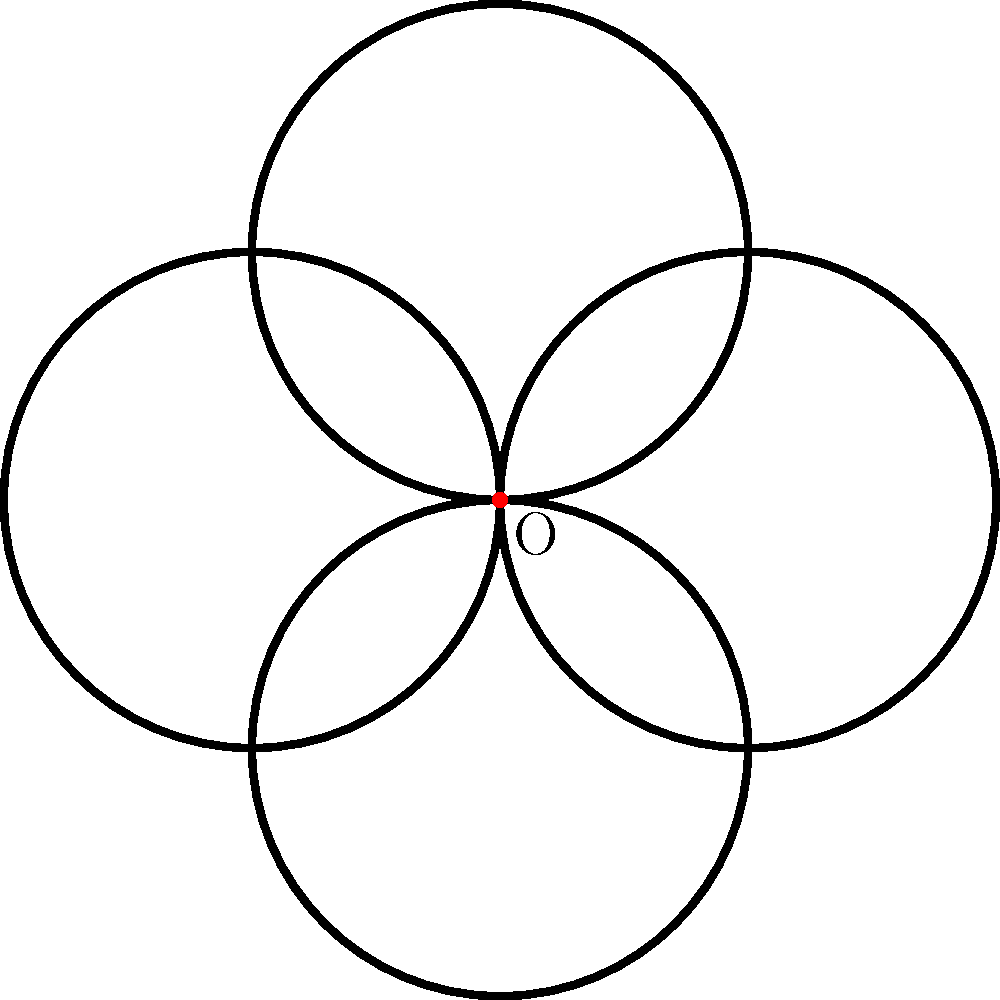In the traditional Maori koru design shown above, four identical spiral elements are arranged around a central point O. What is the minimum angle of rotation needed to map the entire design onto itself? To determine the minimum angle of rotation that maps the entire koru design onto itself, we need to analyze its symmetry properties:

1. The design consists of four identical spiral elements arranged around a central point O.

2. Each spiral element occupies one quadrant of the circular design.

3. The design has rotational symmetry, meaning it can be rotated by a certain angle and appear unchanged.

4. To find the minimum angle, we need to determine the smallest rotation that brings the design back to its original position.

5. Since there are four identical elements evenly distributed around 360°, we can calculate the minimum rotation angle as:

   $$\text{Minimum rotation angle} = \frac{360°}{\text{Number of elements}} = \frac{360°}{4} = 90°$$

6. Rotating the design by 90° clockwise or counterclockwise will map each spiral element onto the position of its neighboring element, thus preserving the overall appearance of the design.

Therefore, the minimum angle of rotation needed to map the entire koru design onto itself is 90°.
Answer: 90° 